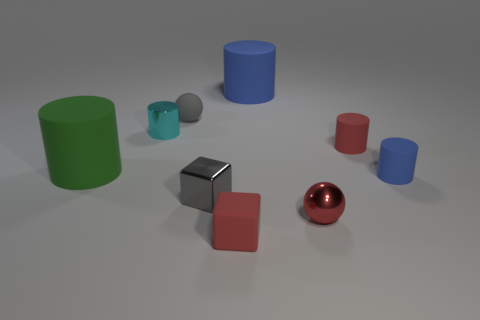Subtract all metallic cylinders. How many cylinders are left? 4 Subtract all green cylinders. How many cylinders are left? 4 Subtract all brown cylinders. Subtract all brown blocks. How many cylinders are left? 5 Add 1 tiny blue metal cubes. How many objects exist? 10 Subtract all blocks. How many objects are left? 7 Add 1 small red spheres. How many small red spheres are left? 2 Add 4 red objects. How many red objects exist? 7 Subtract 2 blue cylinders. How many objects are left? 7 Subtract all brown metal blocks. Subtract all large blue rubber things. How many objects are left? 8 